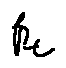Convert formula to latex. <formula><loc_0><loc_0><loc_500><loc_500>\beta _ { t }</formula> 